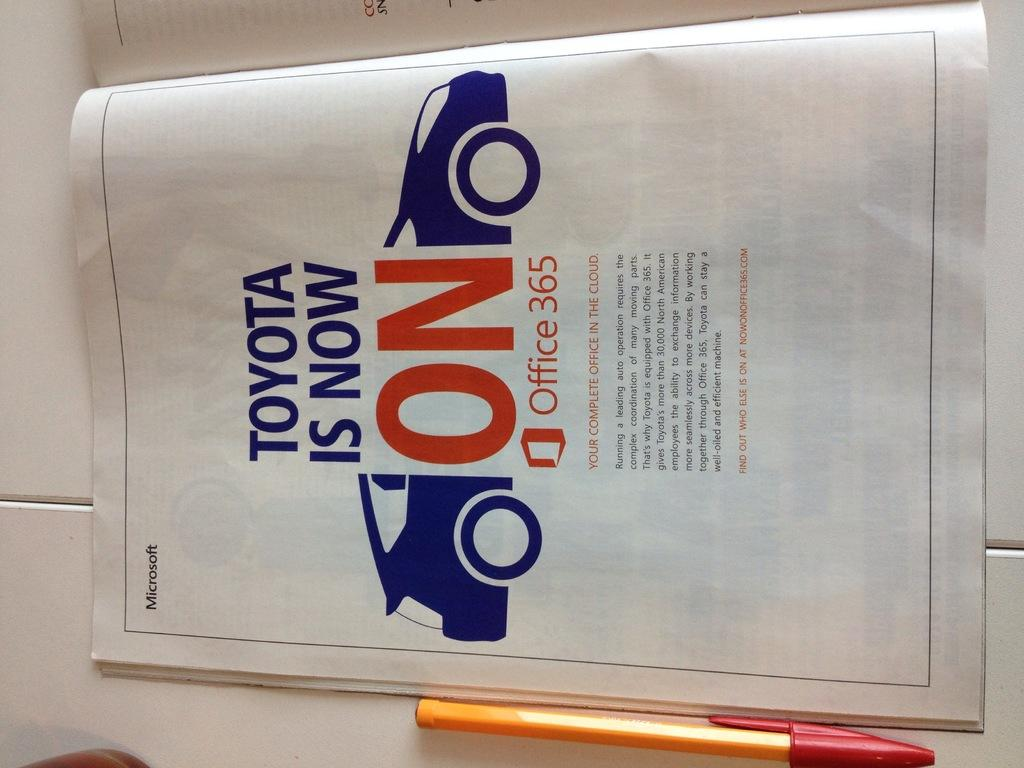<image>
Share a concise interpretation of the image provided. A promotional brochure is about Office 365 having Toyota on it. 